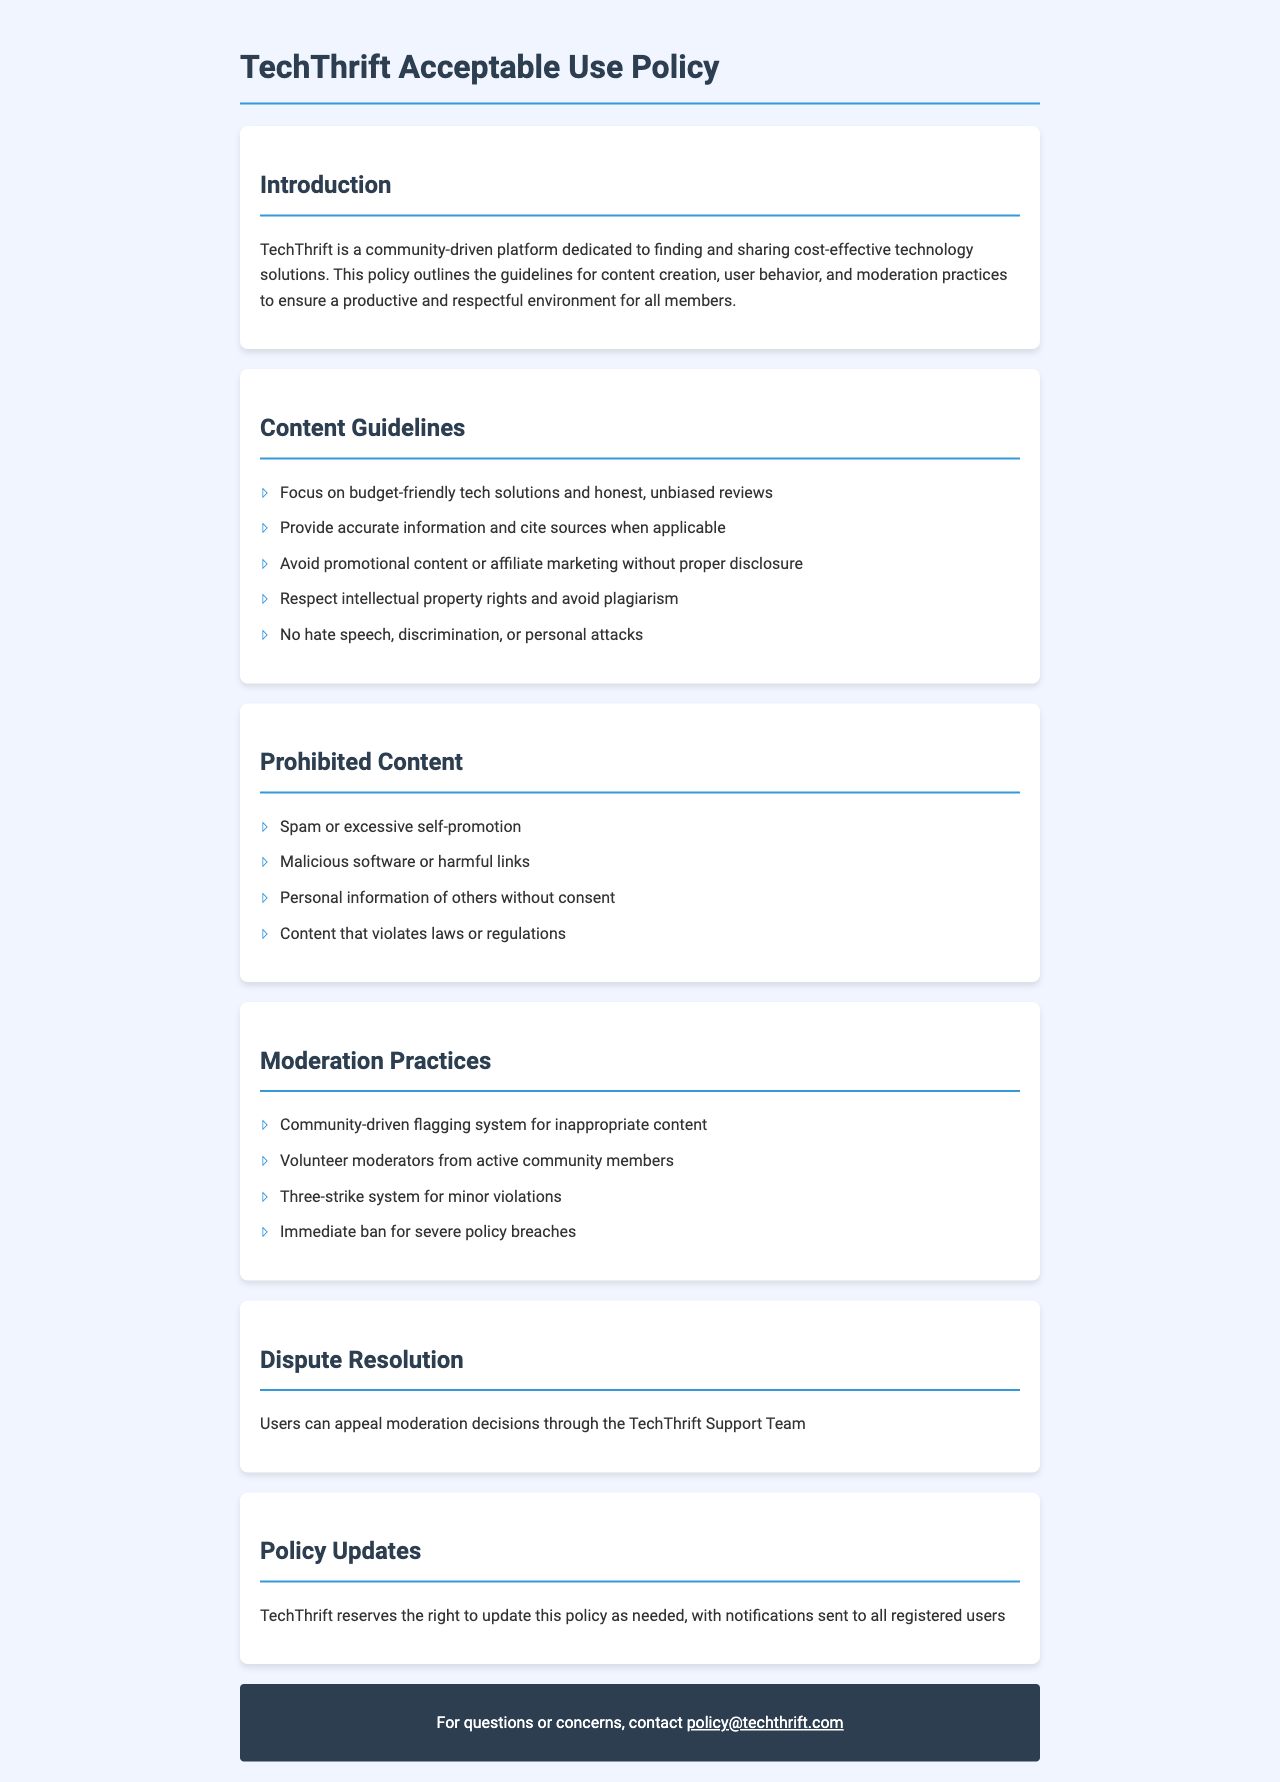What is the title of the document? The title of the document is mentioned in the header of the HTML document.
Answer: TechThrift Acceptable Use Policy What is the main focus of TechThrift? This information is found in the introduction section, detailing what TechThrift is dedicated to.
Answer: Budget-friendly technology solutions What content is prohibited on the platform? This can be found in the "Prohibited Content" section, listing specific types of content not allowed.
Answer: Spam or excessive self-promotion How many strikes are allowed before facing a ban? The document details the moderation practices including a three-strike system.
Answer: Three What type of moderation system does TechThrift use? The "Moderation Practices" section describes the system employed for moderated content.
Answer: Community-driven flagging system Who can appeal moderation decisions? The "Dispute Resolution" section clarifies who is responsible for resolving disputes.
Answer: Users What should users avoid when creating content? The "Content Guidelines" section lists what is expected from users contributing content.
Answer: Promotional content or affiliate marketing without proper disclosure What happens after a severe policy breach? The "Moderation Practices" section specifies the consequence of severe violations.
Answer: Immediate ban How can users contact for policy-related questions? The contact information is provided at the end of the document where users can find the email address for inquiries.
Answer: policy@techthrift.com 